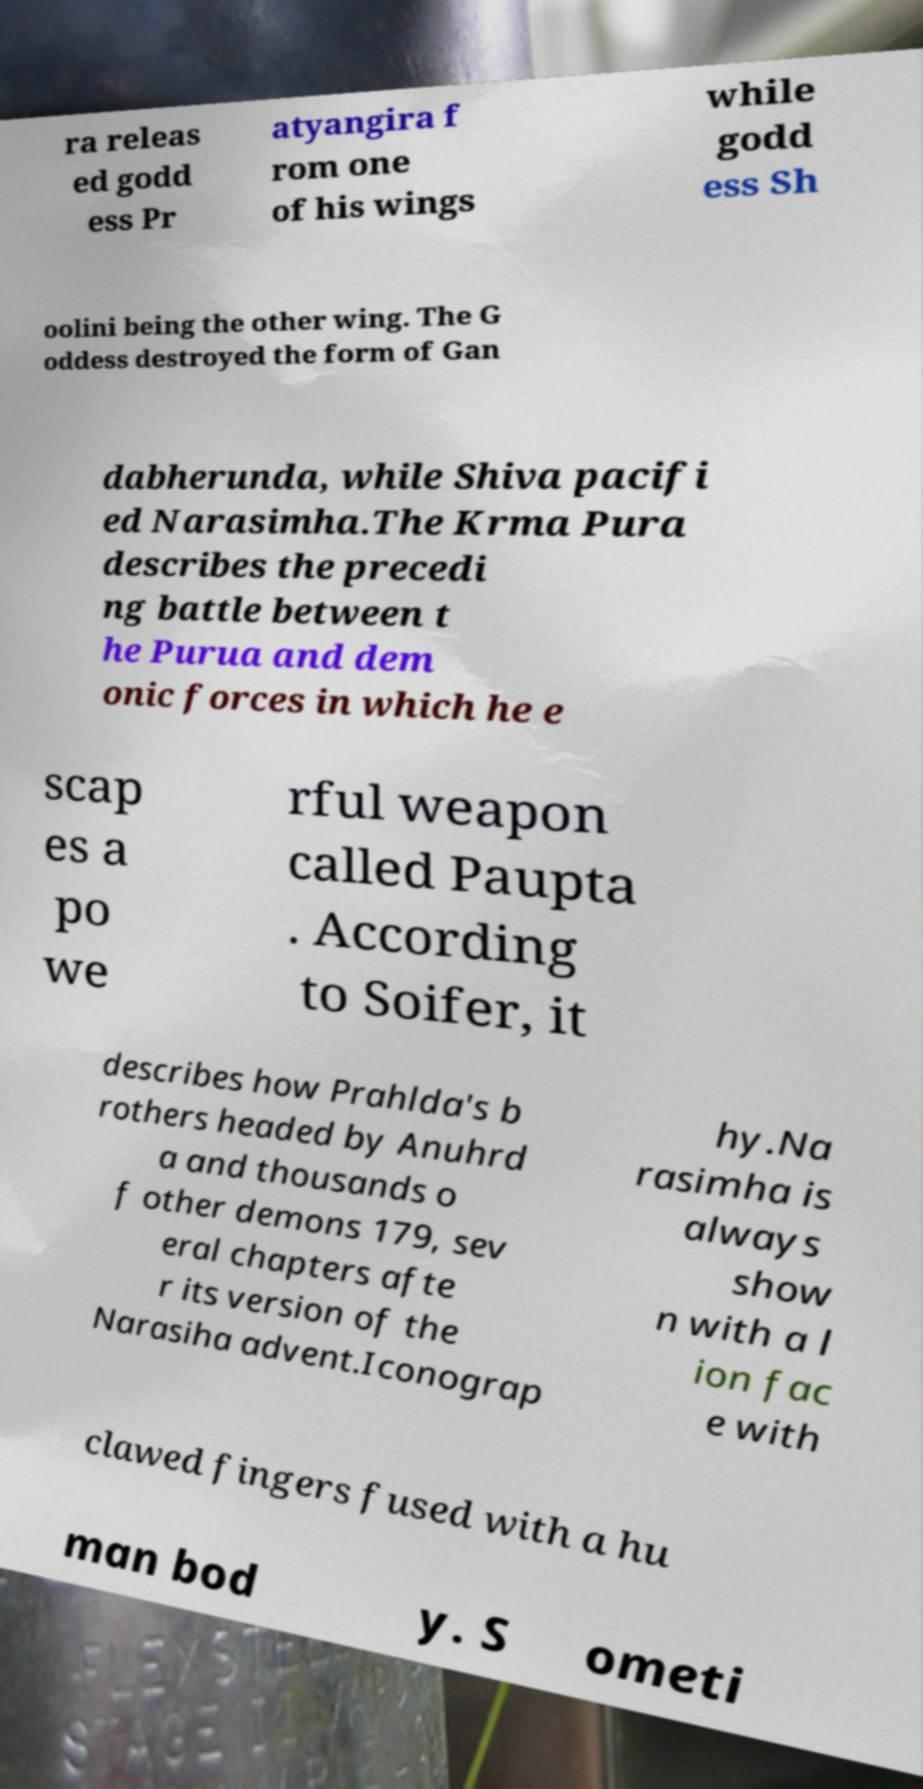Can you accurately transcribe the text from the provided image for me? ra releas ed godd ess Pr atyangira f rom one of his wings while godd ess Sh oolini being the other wing. The G oddess destroyed the form of Gan dabherunda, while Shiva pacifi ed Narasimha.The Krma Pura describes the precedi ng battle between t he Purua and dem onic forces in which he e scap es a po we rful weapon called Paupta . According to Soifer, it describes how Prahlda's b rothers headed by Anuhrd a and thousands o f other demons 179, sev eral chapters afte r its version of the Narasiha advent.Iconograp hy.Na rasimha is always show n with a l ion fac e with clawed fingers fused with a hu man bod y. S ometi 